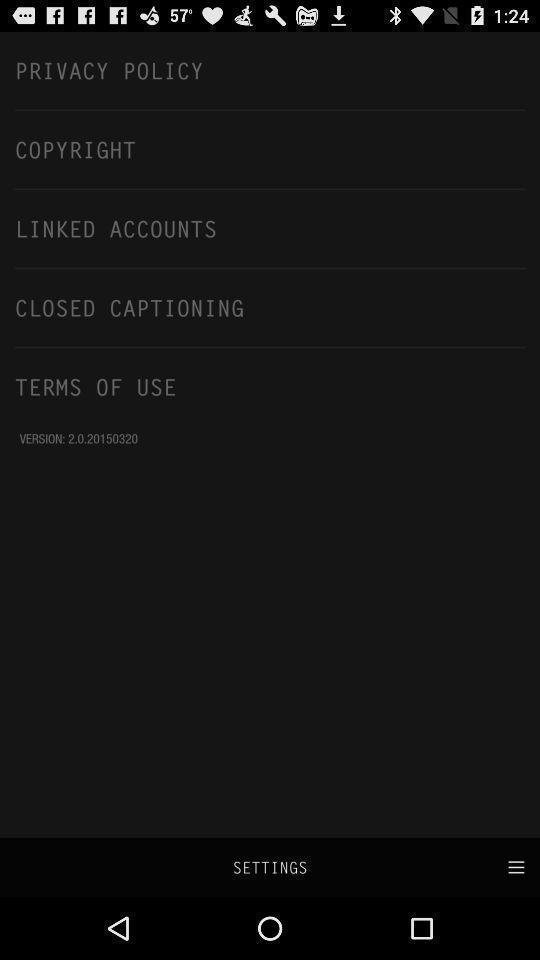Give me a narrative description of this picture. Settings page with few options. 